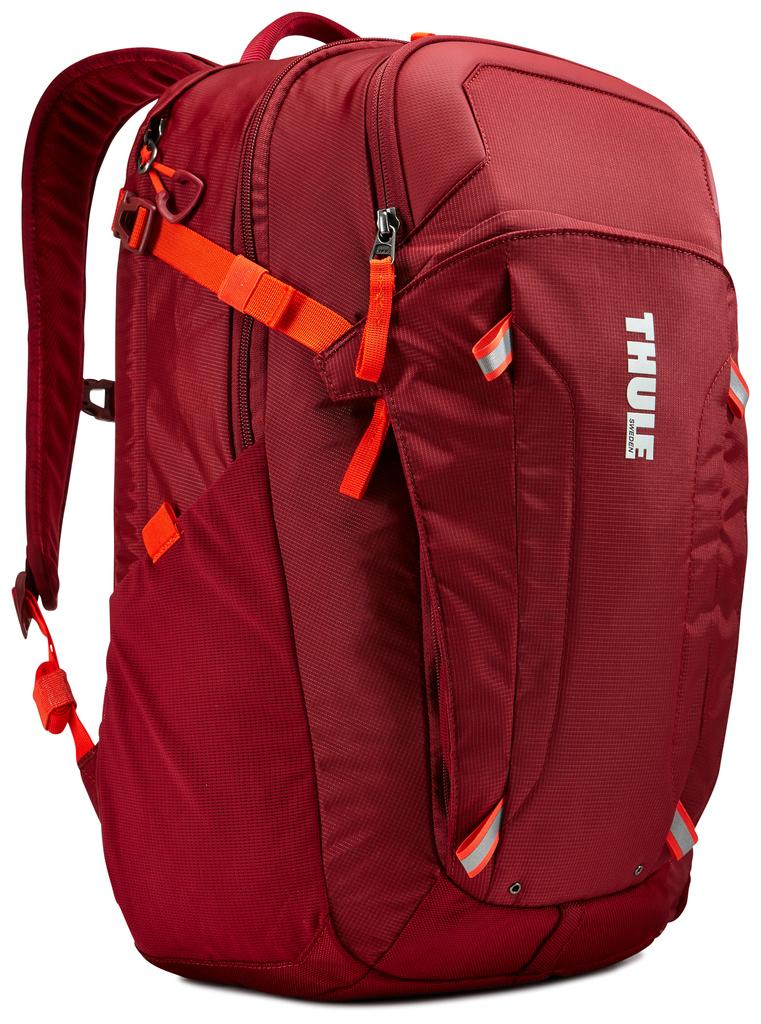<image>
Give a short and clear explanation of the subsequent image. an ad for a red back pack from Thule Sweden 